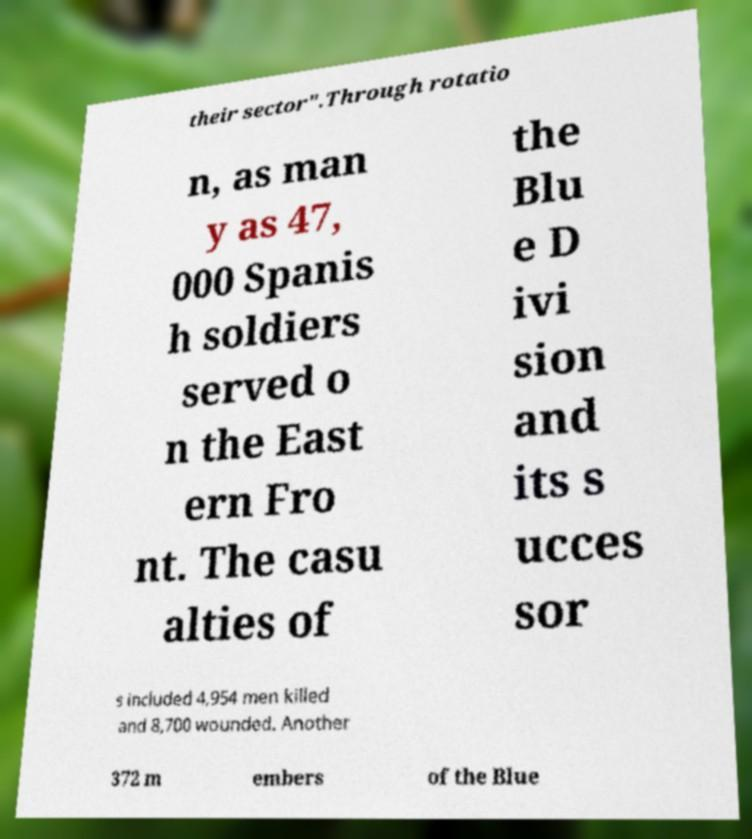Please identify and transcribe the text found in this image. their sector".Through rotatio n, as man y as 47, 000 Spanis h soldiers served o n the East ern Fro nt. The casu alties of the Blu e D ivi sion and its s ucces sor s included 4,954 men killed and 8,700 wounded. Another 372 m embers of the Blue 